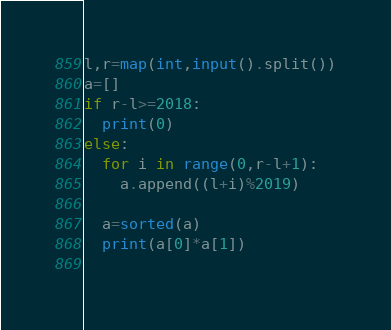<code> <loc_0><loc_0><loc_500><loc_500><_Python_>l,r=map(int,input().split())
a=[]
if r-l>=2018:
  print(0)
else:
  for i in range(0,r-l+1):
    a.append((l+i)%2019)
  
  a=sorted(a)
  print(a[0]*a[1])
    
</code> 